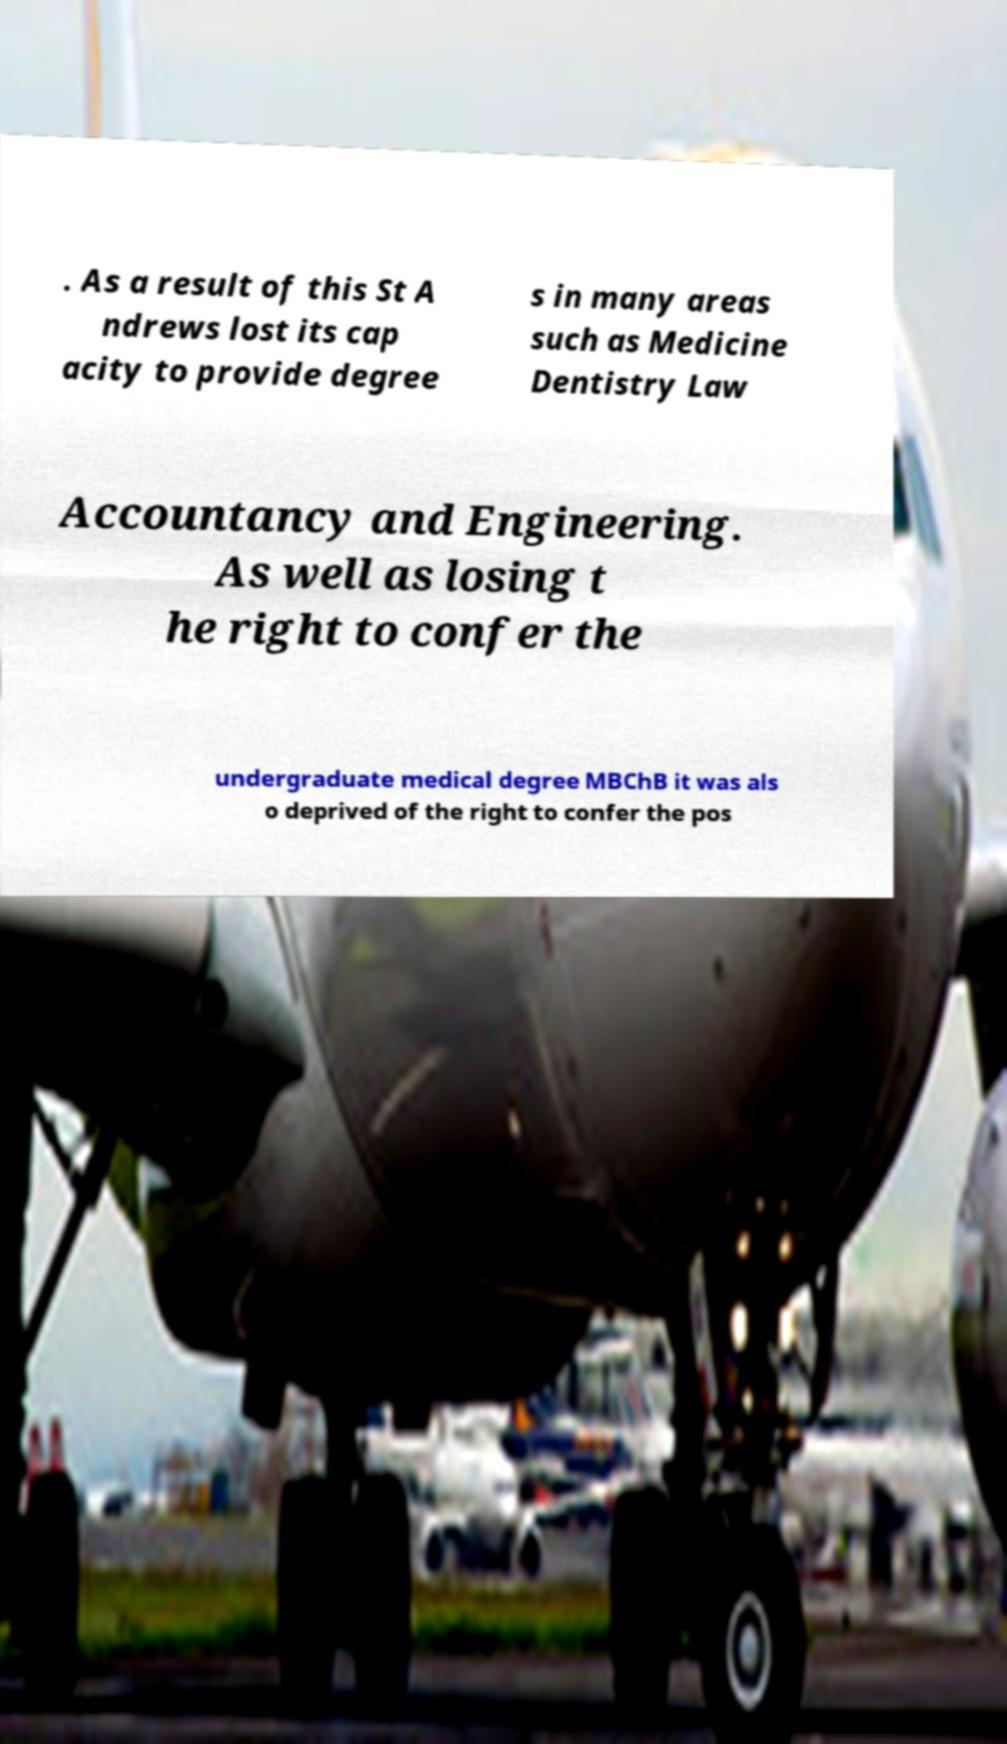Could you assist in decoding the text presented in this image and type it out clearly? . As a result of this St A ndrews lost its cap acity to provide degree s in many areas such as Medicine Dentistry Law Accountancy and Engineering. As well as losing t he right to confer the undergraduate medical degree MBChB it was als o deprived of the right to confer the pos 